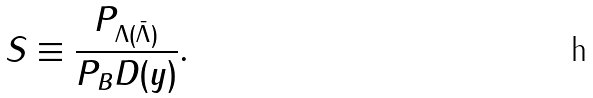Convert formula to latex. <formula><loc_0><loc_0><loc_500><loc_500>S \equiv \frac { P _ { \Lambda ( \bar { \Lambda } ) } } { P _ { B } D ( y ) } .</formula> 